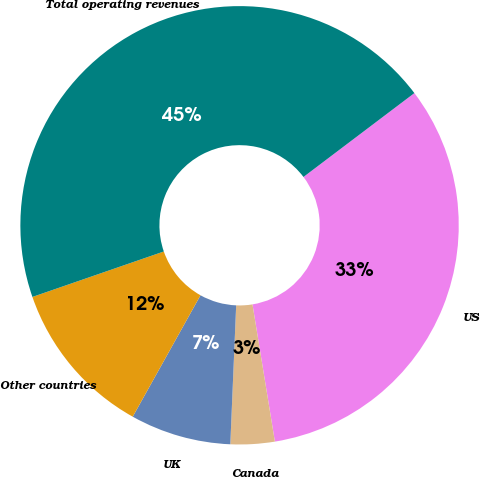<chart> <loc_0><loc_0><loc_500><loc_500><pie_chart><fcel>US<fcel>Canada<fcel>UK<fcel>Other countries<fcel>Total operating revenues<nl><fcel>32.73%<fcel>3.25%<fcel>7.43%<fcel>11.6%<fcel>45.0%<nl></chart> 